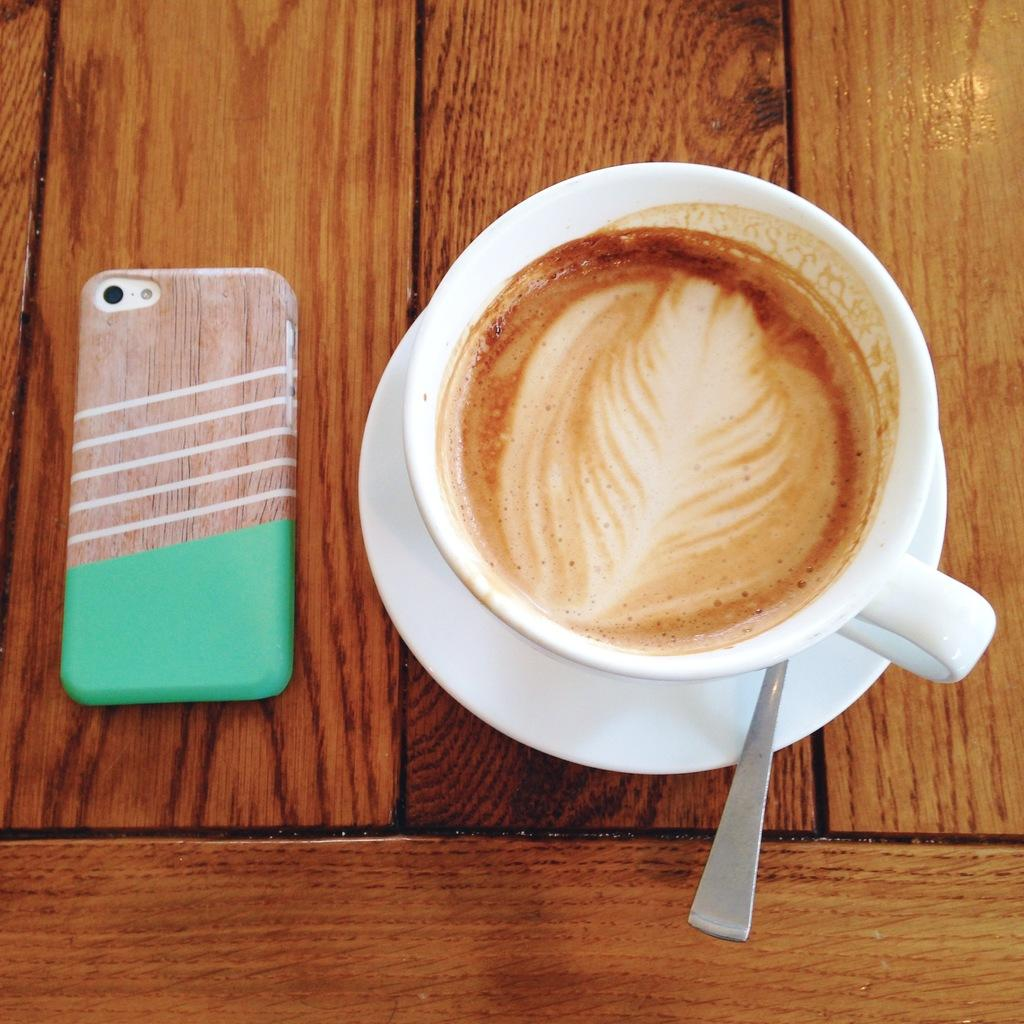What type of dishware is present in the image? There is a teacup and a saucer in the image. What utensil is visible in the image? There is a spoon in the image. What is located on the left side of the image? A mobile is visible on the left side of the image. Where are all these items placed? All these items are placed on a table. What type of flooring can be seen under the table in the image? The provided facts do not mention the flooring or any floor-related details in the image. --- Facts: 1. There is a person sitting on a chair in the image. 2. The person is holding a book. 3. The book has a red cover. 4. There is a lamp on the table next to the chair. 5. The room has a wooden floor. Absurd Topics: ocean, parrot, bicycle Conversation: What is the person in the image doing? The person is sitting on a chair in the image. What object is the person holding? The person is holding a book. What is the color of the book's cover? The book has a red cover. What is located on the table next to the chair? There is a lamp on the table next to the chair. What type of flooring is present in the room? The room has a wooden floor. Reasoning: Let's think step by step in order to produce the conversation. We start by describing the main subject in the image, which is the person sitting on a chair. Then, we mention the object the person is holding, which is a book with a red cover. Next, we describe the lamp on the table next to the chair. Finally, we clarify the type of flooring in the room, which is wooden. Absurd Question/Answer: Can you tell me how many parrots are sitting on the bicycle in the image? There is no bicycle or parrot present in the image. 